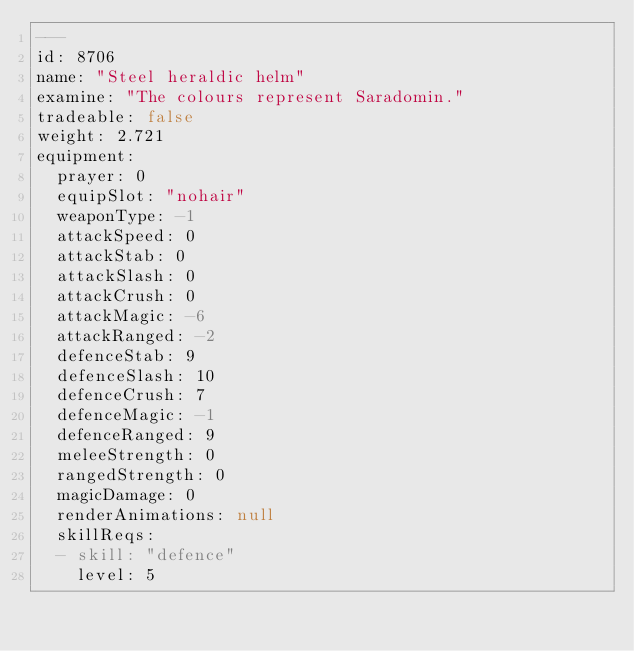Convert code to text. <code><loc_0><loc_0><loc_500><loc_500><_YAML_>---
id: 8706
name: "Steel heraldic helm"
examine: "The colours represent Saradomin."
tradeable: false
weight: 2.721
equipment:
  prayer: 0
  equipSlot: "nohair"
  weaponType: -1
  attackSpeed: 0
  attackStab: 0
  attackSlash: 0
  attackCrush: 0
  attackMagic: -6
  attackRanged: -2
  defenceStab: 9
  defenceSlash: 10
  defenceCrush: 7
  defenceMagic: -1
  defenceRanged: 9
  meleeStrength: 0
  rangedStrength: 0
  magicDamage: 0
  renderAnimations: null
  skillReqs:
  - skill: "defence"
    level: 5
</code> 